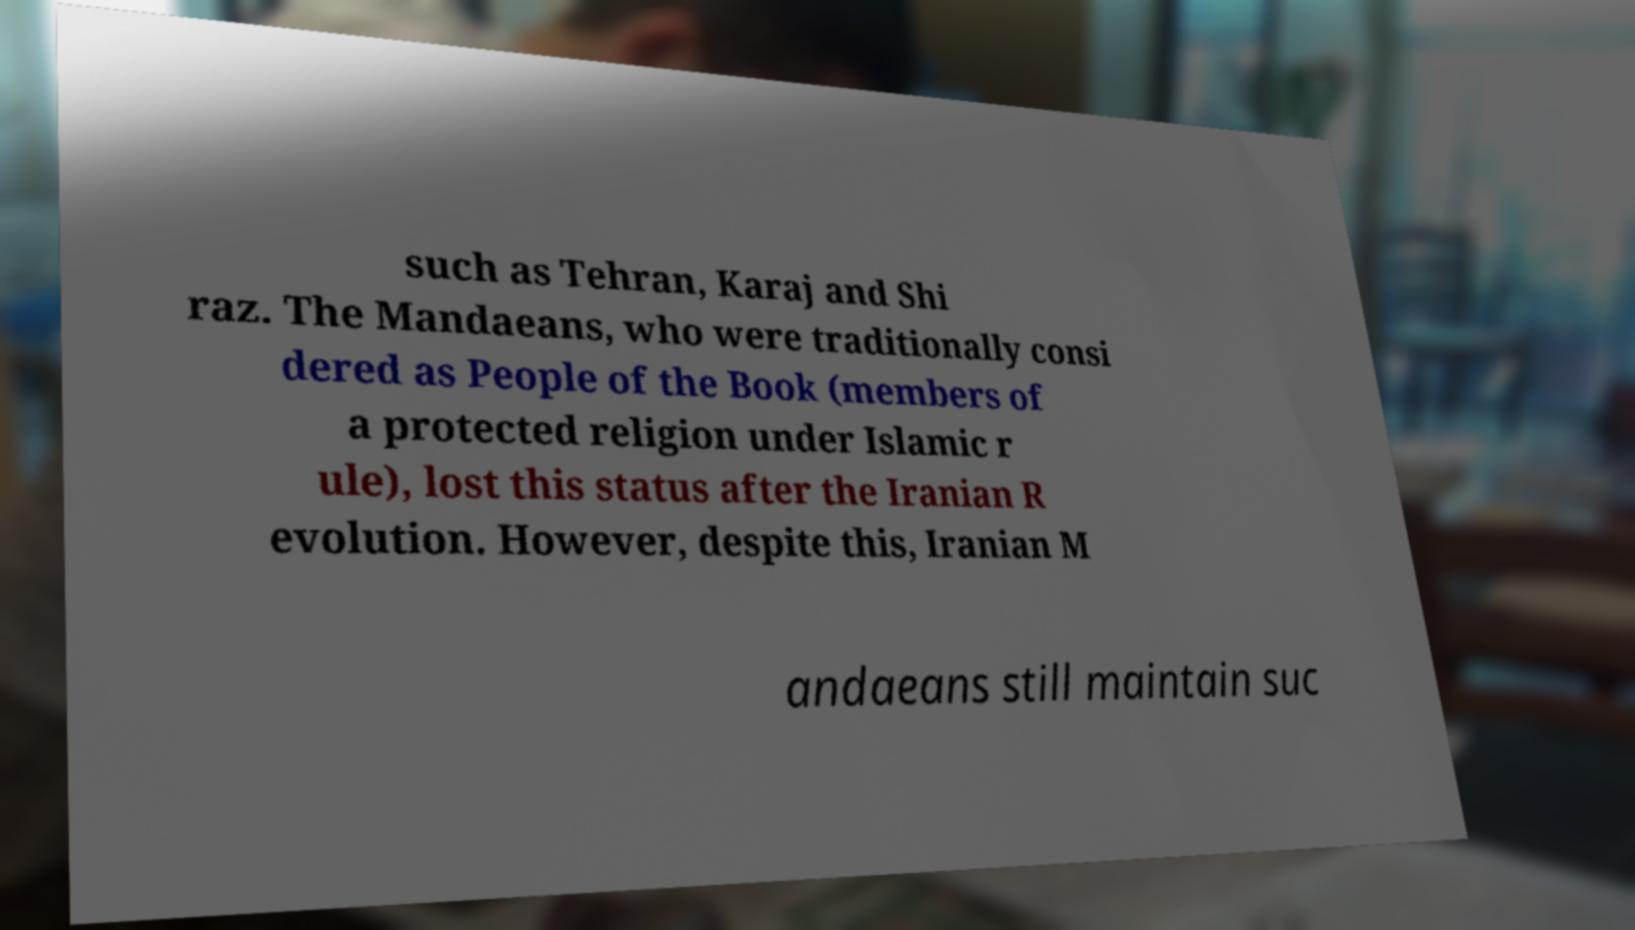Please identify and transcribe the text found in this image. such as Tehran, Karaj and Shi raz. The Mandaeans, who were traditionally consi dered as People of the Book (members of a protected religion under Islamic r ule), lost this status after the Iranian R evolution. However, despite this, Iranian M andaeans still maintain suc 